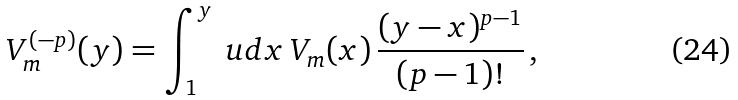Convert formula to latex. <formula><loc_0><loc_0><loc_500><loc_500>V _ { m } ^ { ( - p ) } ( y ) = \int _ { 1 } ^ { y } \ u d x \, V _ { m } ( x ) \, \frac { ( y - x ) ^ { p - 1 } } { ( p - 1 ) ! } \, ,</formula> 